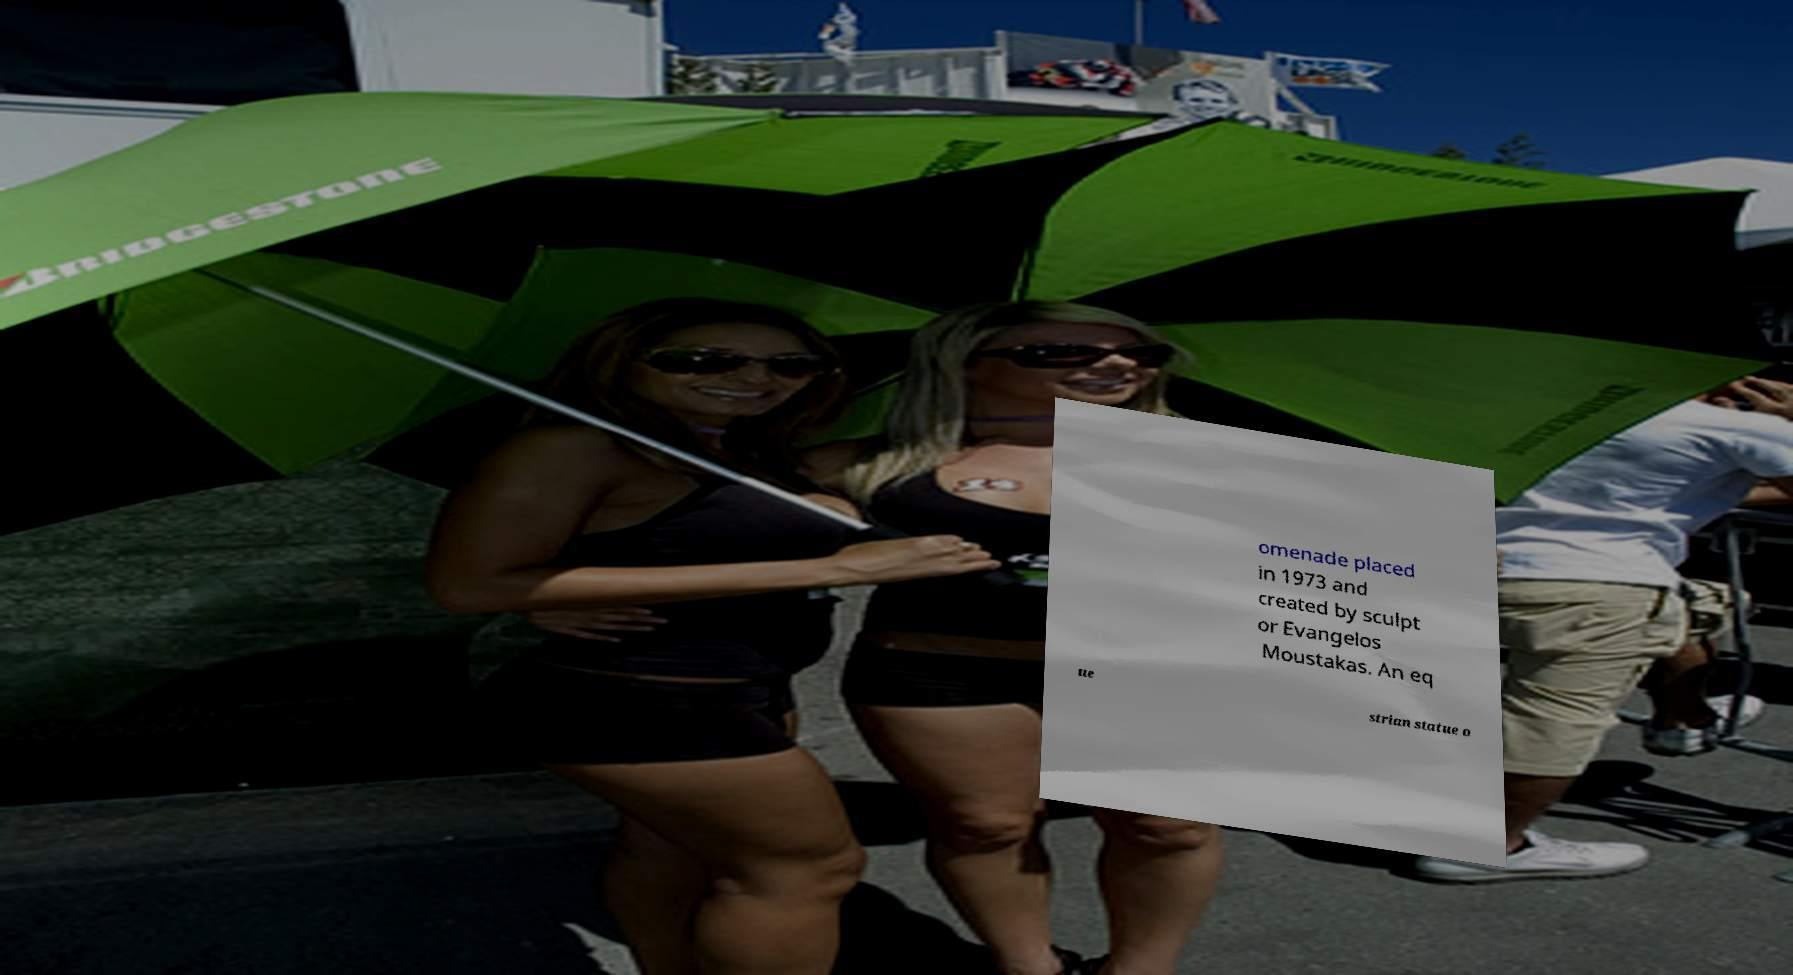For documentation purposes, I need the text within this image transcribed. Could you provide that? omenade placed in 1973 and created by sculpt or Evangelos Moustakas. An eq ue strian statue o 